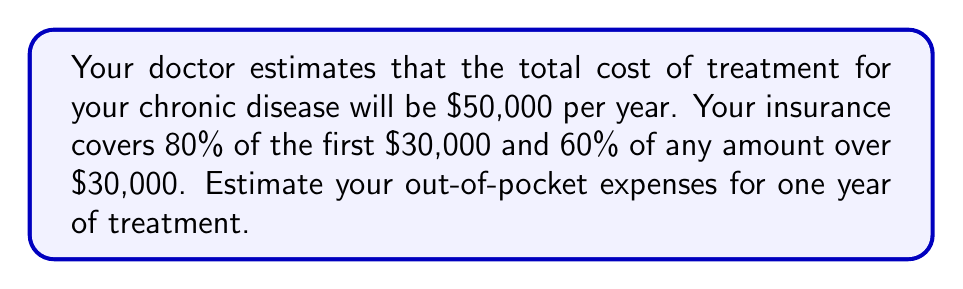Solve this math problem. Let's break this down step-by-step:

1) First, calculate the insurance coverage for the first $30,000:
   $$ 80\% \text{ of } \$30,000 = 0.80 \times \$30,000 = \$24,000 $$

2) Calculate your out-of-pocket expense for the first $30,000:
   $$ \$30,000 - \$24,000 = \$6,000 $$

3) Calculate the remaining amount above $30,000:
   $$ \$50,000 - \$30,000 = \$20,000 $$

4) Calculate the insurance coverage for the amount over $30,000:
   $$ 60\% \text{ of } \$20,000 = 0.60 \times \$20,000 = \$12,000 $$

5) Calculate your out-of-pocket expense for the amount over $30,000:
   $$ \$20,000 - \$12,000 = \$8,000 $$

6) Sum up your total out-of-pocket expenses:
   $$ \$6,000 + \$8,000 = \$14,000 $$

Therefore, your estimated out-of-pocket expenses for one year of treatment would be $14,000.
Answer: $14,000 